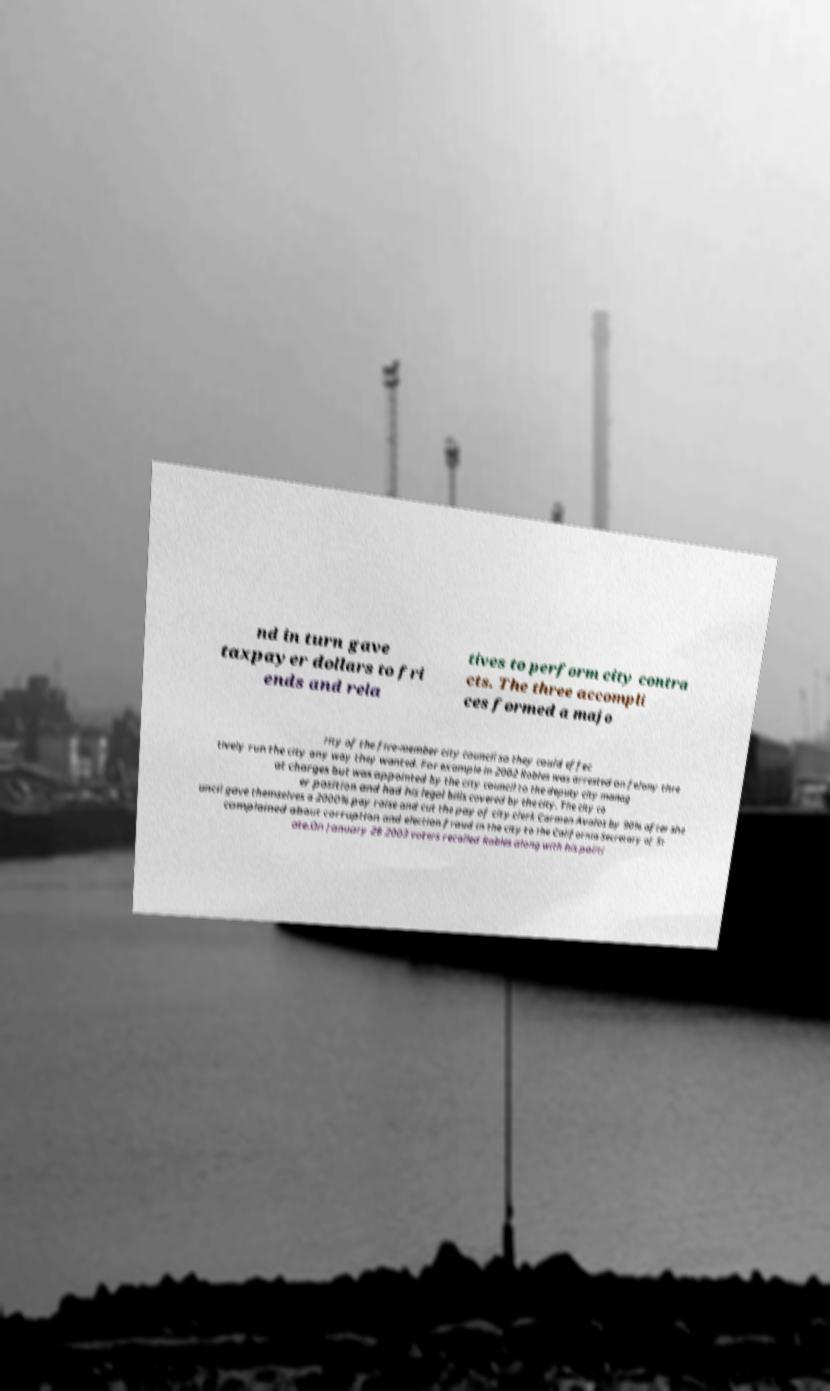I need the written content from this picture converted into text. Can you do that? nd in turn gave taxpayer dollars to fri ends and rela tives to perform city contra cts. The three accompli ces formed a majo rity of the five-member city council so they could effec tively run the city any way they wanted. For example in 2002 Robles was arrested on felony thre at charges but was appointed by the city council to the deputy city manag er position and had his legal bills covered by the city. The city co uncil gave themselves a 2000% pay raise and cut the pay of city clerk Carmen Avalos by 90% after she complained about corruption and election fraud in the city to the California Secretary of St ate.On January 28 2003 voters recalled Robles along with his politi 